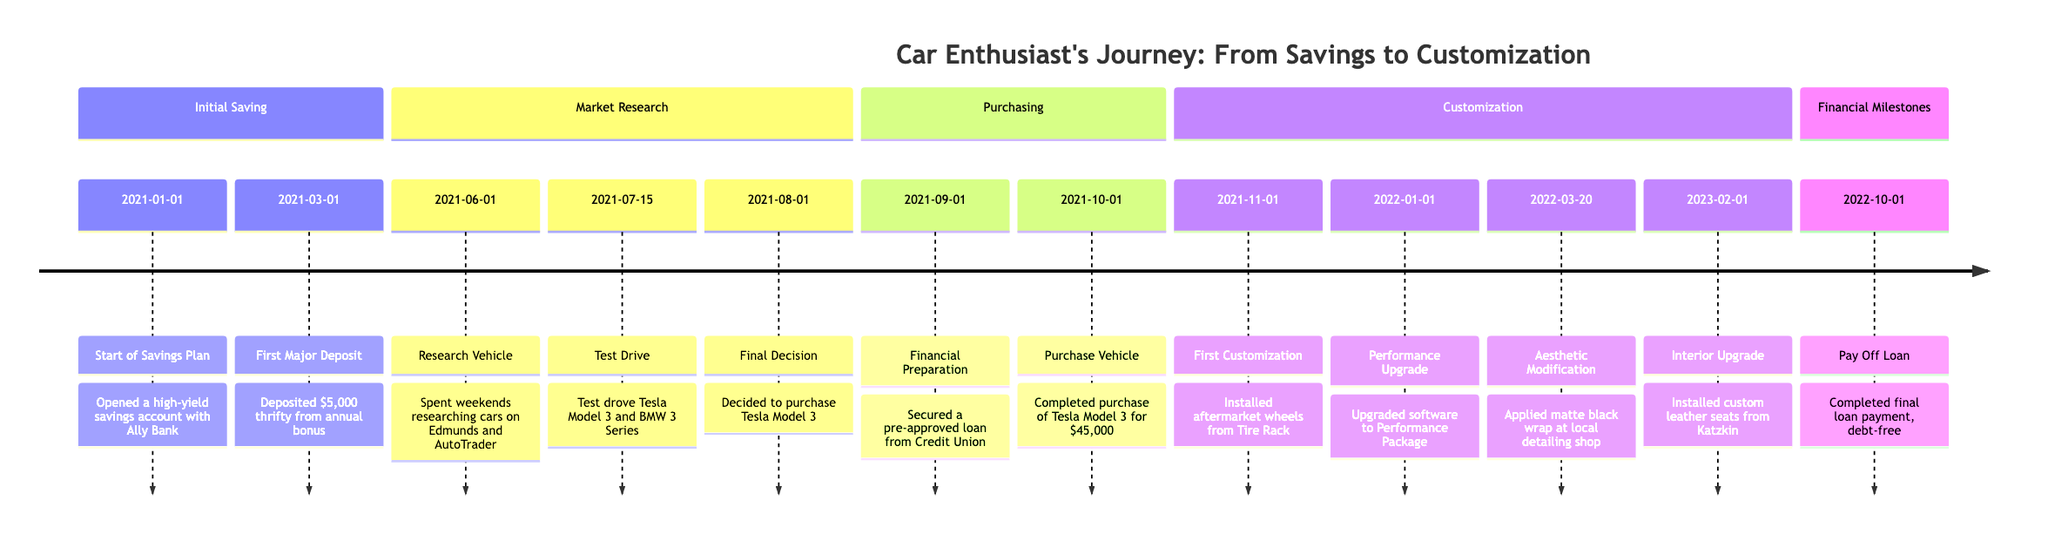What was the first major deposit? The milestone labeled "First Major Deposit" in the "Initial Saving" stage shows that a deposit of $5,000 was made.
Answer: $5,000 What vehicle was test-driven on 2021-07-15? The "Test Drive" milestone specifically mentions two vehicles: Tesla Model 3 and BMW 3 Series. Since it's a specific question about what was test-driven on that date, both names can be noted.
Answer: Tesla Model 3 and BMW 3 Series How many customization milestones are there? By counting the milestones listed under the "Customization" section, we find four entries: First Customization, Performance Upgrade, Aesthetic Modification, and Interior Upgrade. This gives us a total of four customization milestones.
Answer: 4 What was the final decision made on 2021-08-01? The milestone states that the decision was made to purchase Tesla Model 3, which is noted in the "Market Research" section.
Answer: Purchase Tesla Model 3 When was the loan paid off? The "Pay Off Loan" milestone is listed in the "Financial Milestones" section, which indicates that the loan was paid off on 2022-10-01.
Answer: 2022-10-01 Which customization involved installing aftermarket wheels? The milestone "First Customization" under the "Customization" section specifies the installation of aftermarket wheels from Tire Rack.
Answer: Aftermarket wheels Which financial preparation was done on 2021-09-01? The "Financial Preparation" milestone notes that a pre-approved loan was secured from the Credit Union, indicating the financial preparation step taken on that date.
Answer: Secured a pre-approved loan What came after the "Performance Upgrade"? Following the "Performance Upgrade" milestone, the next customization milestone listed is "Aesthetic Modification" which occurred on 2022-03-20.
Answer: Aesthetic Modification Where did the high-yield savings account get opened? The "Start of Savings Plan" milestone in the "Initial Saving" stage reveals that the high-yield savings account was opened with Ally Bank.
Answer: Ally Bank 